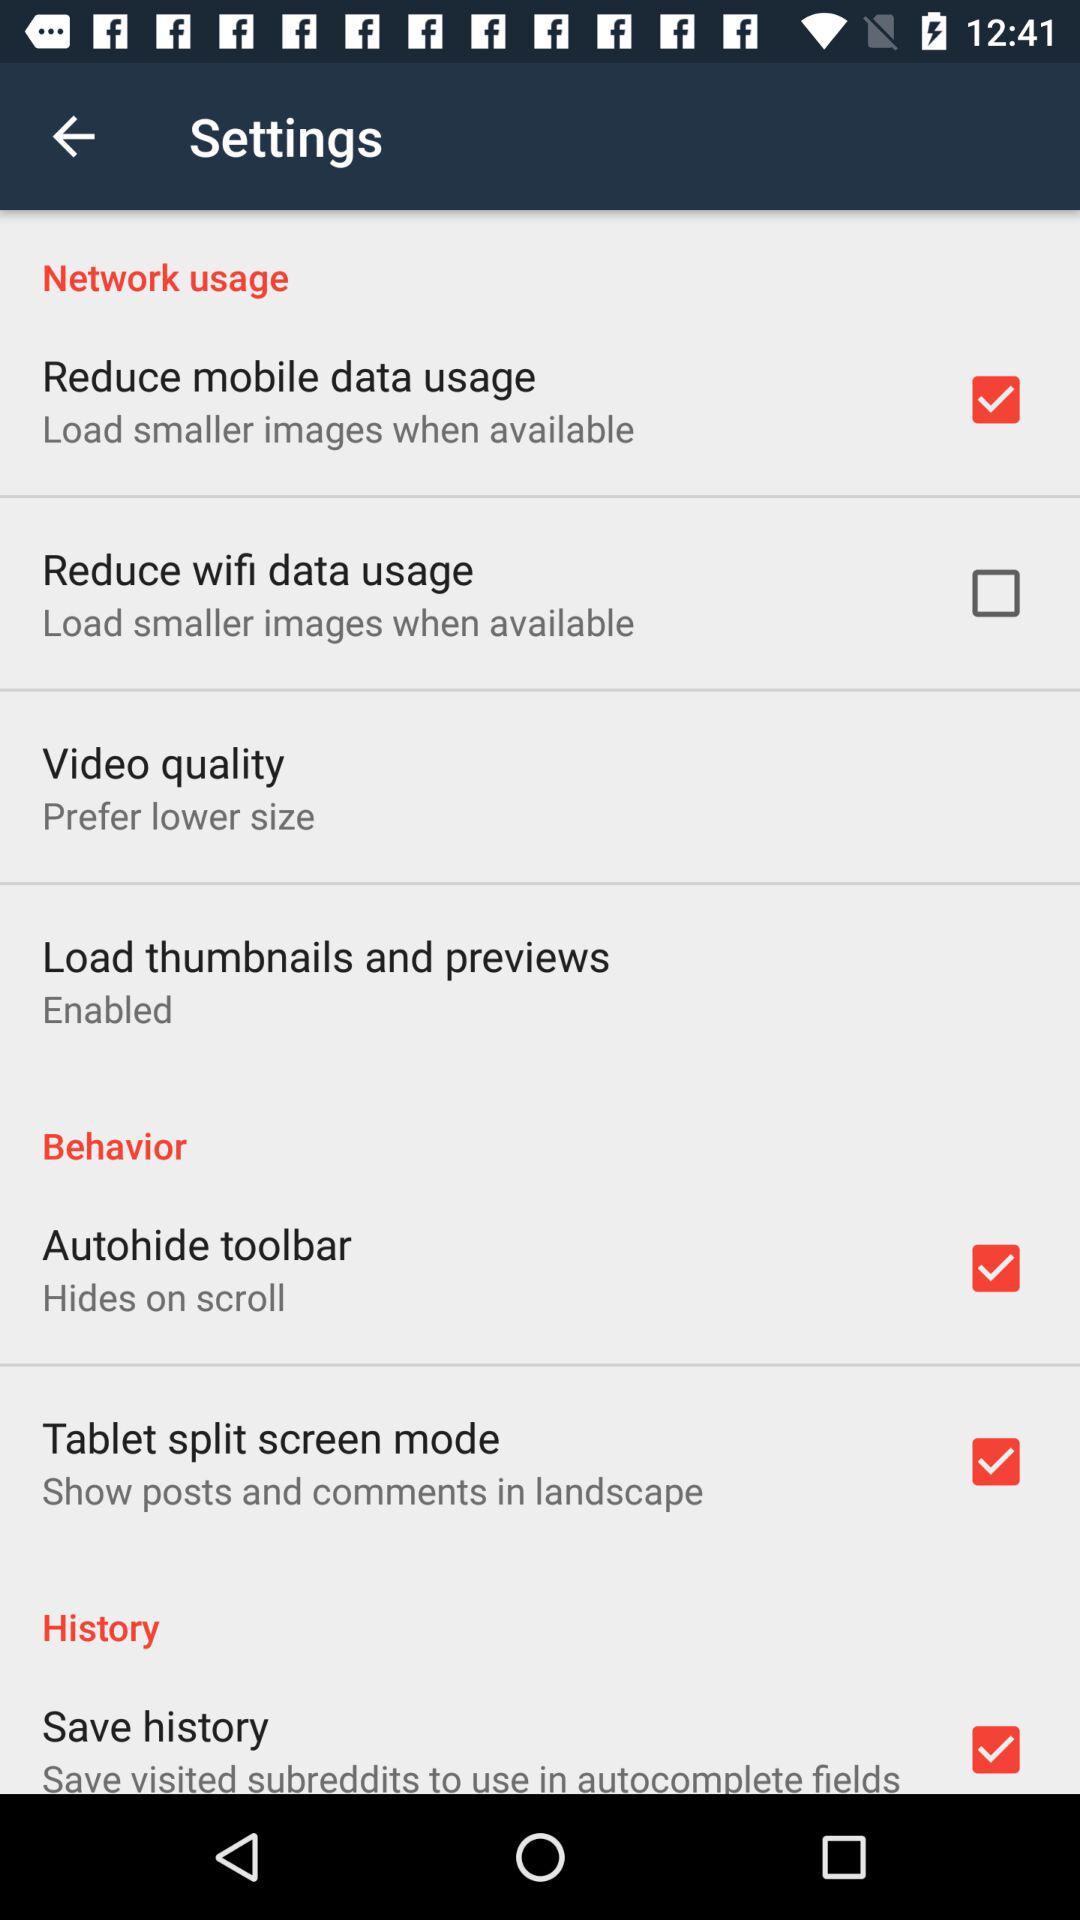How many items are there that allow me to reduce data usage?
Answer the question using a single word or phrase. 2 